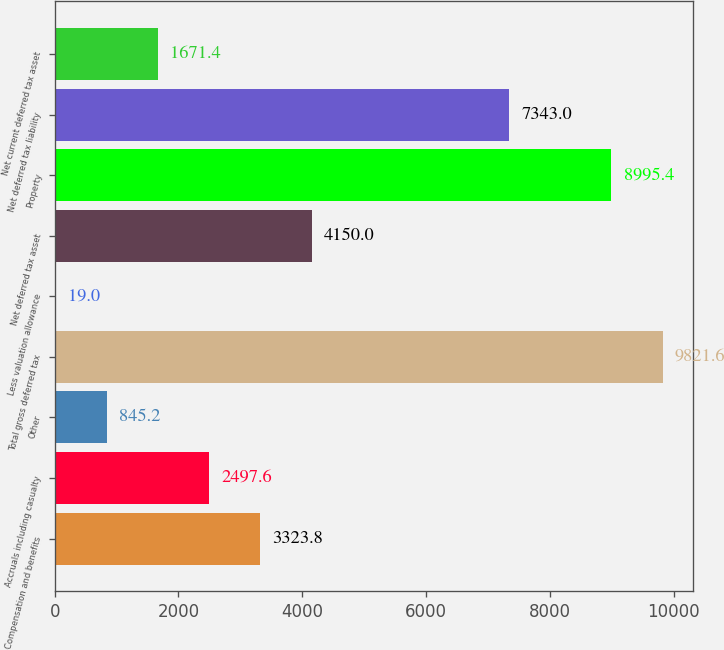Convert chart to OTSL. <chart><loc_0><loc_0><loc_500><loc_500><bar_chart><fcel>Compensation and benefits<fcel>Accruals including casualty<fcel>Other<fcel>Total gross deferred tax<fcel>Less valuation allowance<fcel>Net deferred tax asset<fcel>Property<fcel>Net deferred tax liability<fcel>Net current deferred tax asset<nl><fcel>3323.8<fcel>2497.6<fcel>845.2<fcel>9821.6<fcel>19<fcel>4150<fcel>8995.4<fcel>7343<fcel>1671.4<nl></chart> 